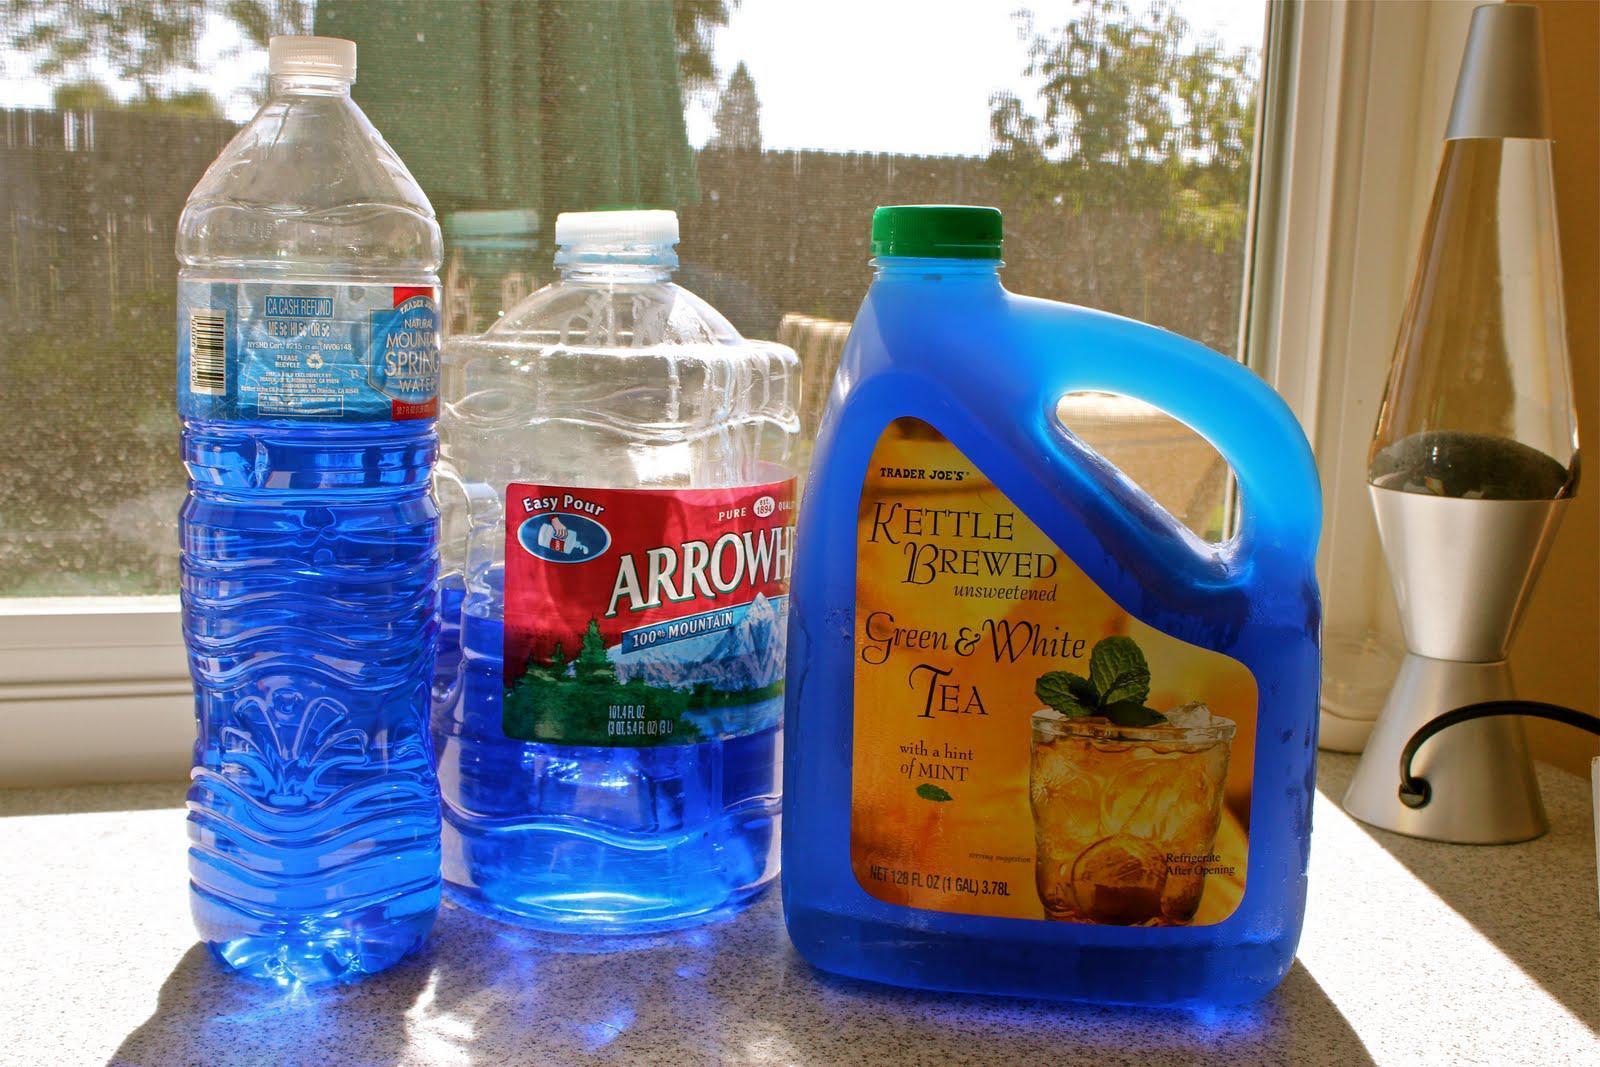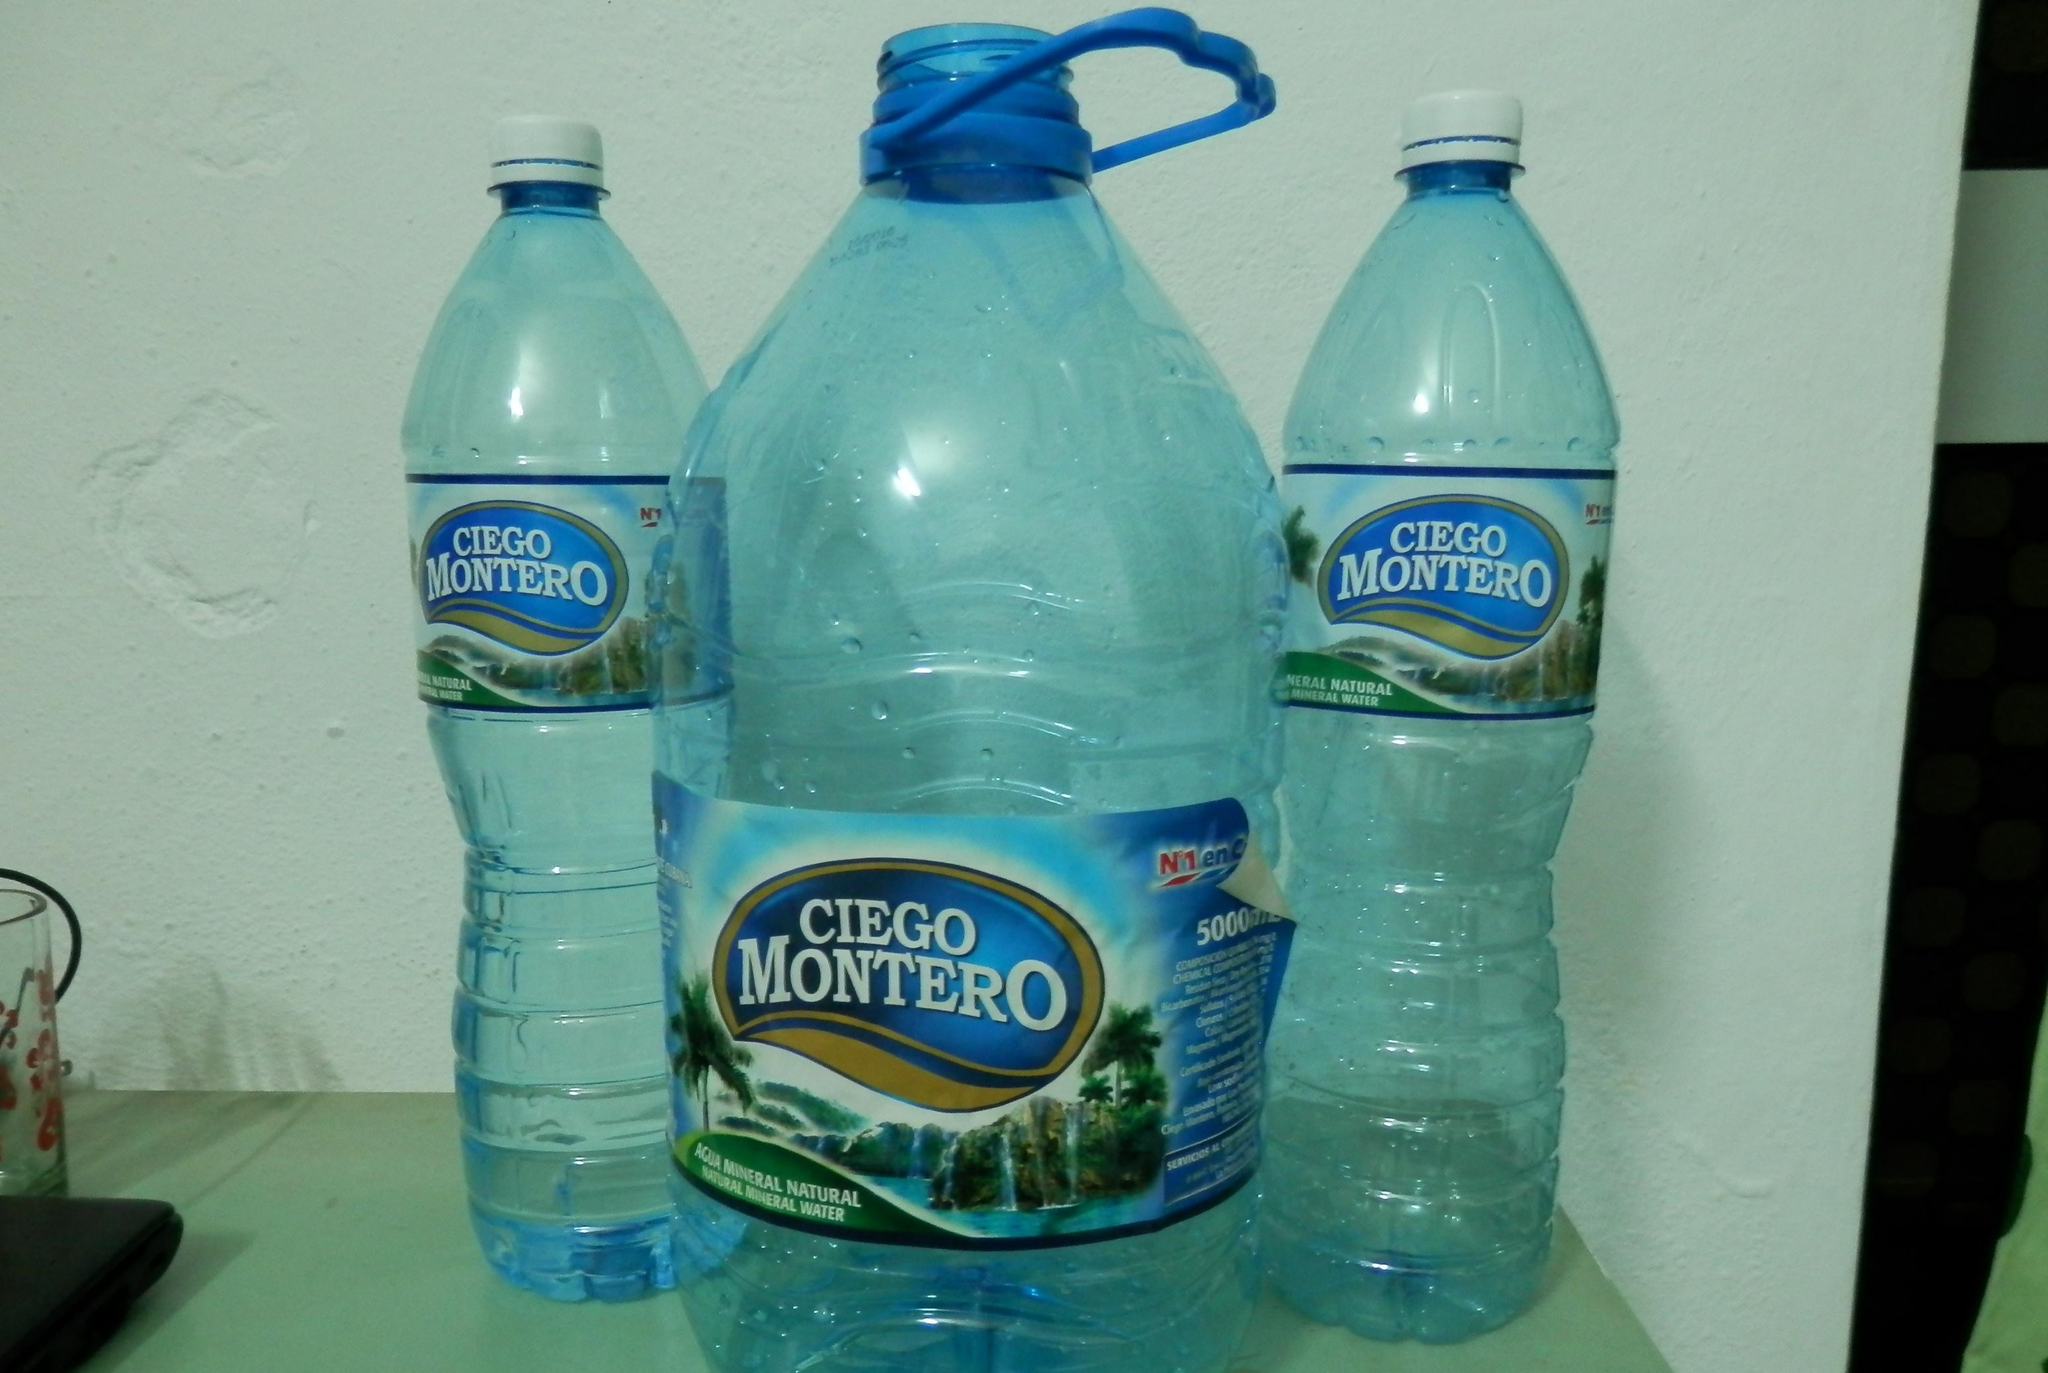The first image is the image on the left, the second image is the image on the right. Assess this claim about the two images: "At least four bottles in the image on the left side have blue lids.". Correct or not? Answer yes or no. No. 